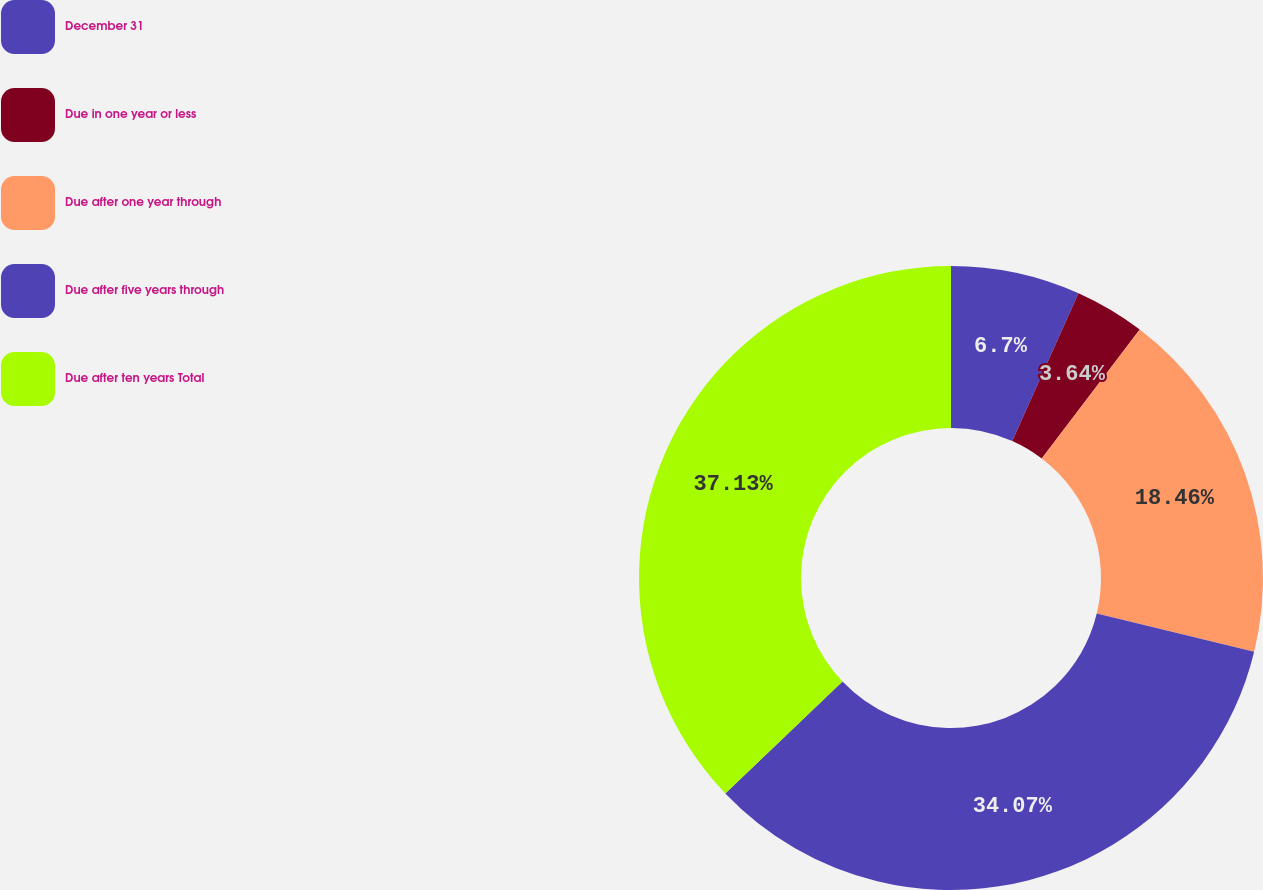Convert chart. <chart><loc_0><loc_0><loc_500><loc_500><pie_chart><fcel>December 31<fcel>Due in one year or less<fcel>Due after one year through<fcel>Due after five years through<fcel>Due after ten years Total<nl><fcel>6.7%<fcel>3.64%<fcel>18.46%<fcel>34.07%<fcel>37.13%<nl></chart> 